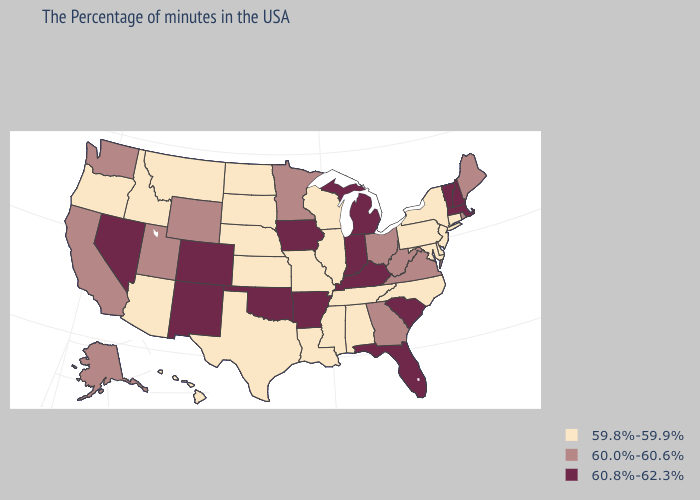Is the legend a continuous bar?
Concise answer only. No. Is the legend a continuous bar?
Give a very brief answer. No. Does Kentucky have a higher value than New Hampshire?
Answer briefly. No. What is the highest value in states that border Arizona?
Concise answer only. 60.8%-62.3%. Does New Mexico have the highest value in the West?
Quick response, please. Yes. What is the value of Montana?
Short answer required. 59.8%-59.9%. Does Arizona have the highest value in the USA?
Be succinct. No. Among the states that border South Dakota , does Montana have the lowest value?
Short answer required. Yes. Does North Carolina have the lowest value in the USA?
Quick response, please. Yes. What is the highest value in the USA?
Keep it brief. 60.8%-62.3%. What is the value of Hawaii?
Write a very short answer. 59.8%-59.9%. Among the states that border Arizona , which have the highest value?
Write a very short answer. Colorado, New Mexico, Nevada. What is the value of Pennsylvania?
Write a very short answer. 59.8%-59.9%. What is the highest value in the USA?
Be succinct. 60.8%-62.3%. How many symbols are there in the legend?
Concise answer only. 3. 